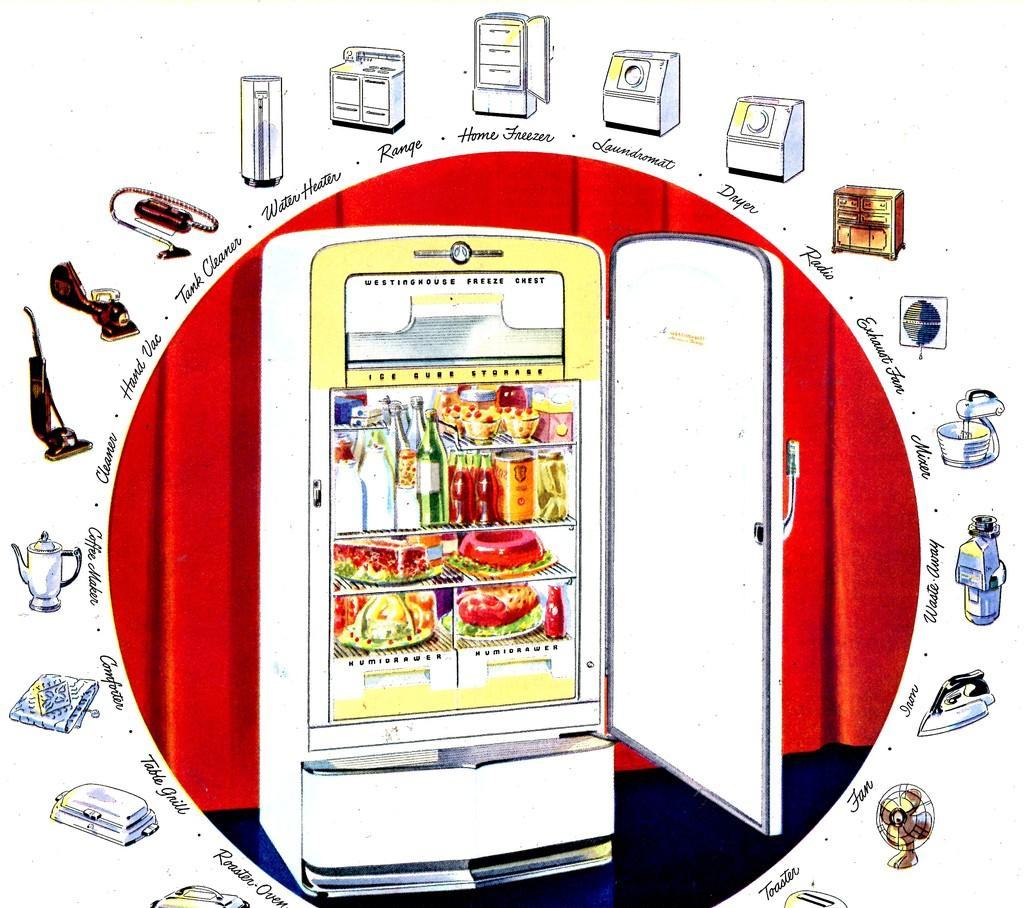<image>
Relay a brief, clear account of the picture shown. a fridge that says ice cube on the front 